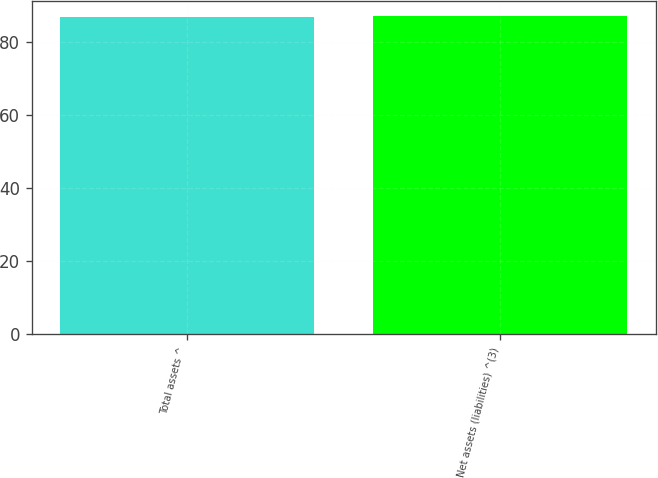Convert chart. <chart><loc_0><loc_0><loc_500><loc_500><bar_chart><fcel>Total assets ^<fcel>Net assets (liabilities) ^(3)<nl><fcel>87<fcel>87.1<nl></chart> 